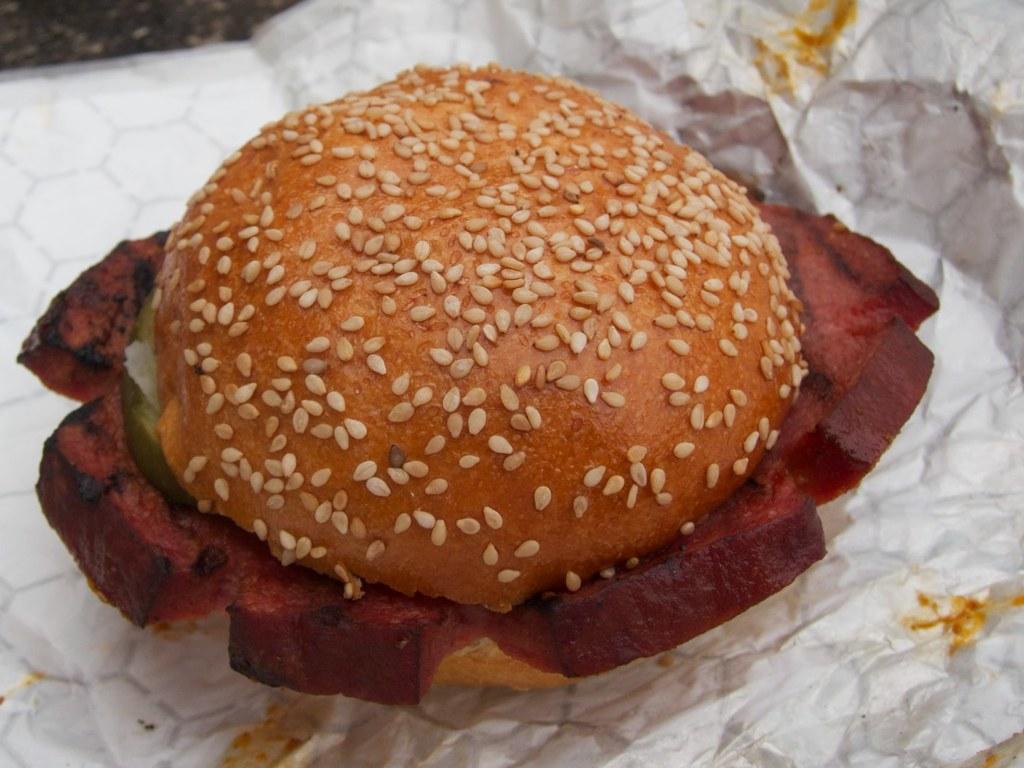Please provide a concise description of this image. In the image it seems like a burger kept on a paper. 